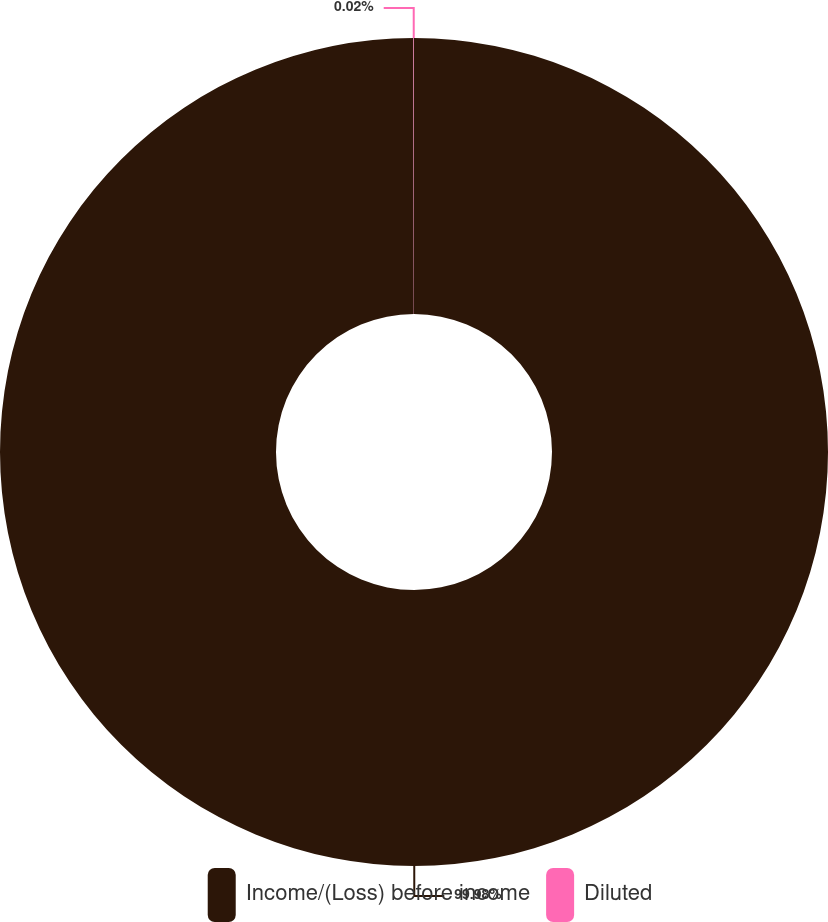Convert chart to OTSL. <chart><loc_0><loc_0><loc_500><loc_500><pie_chart><fcel>Income/(Loss) before income<fcel>Diluted<nl><fcel>99.98%<fcel>0.02%<nl></chart> 